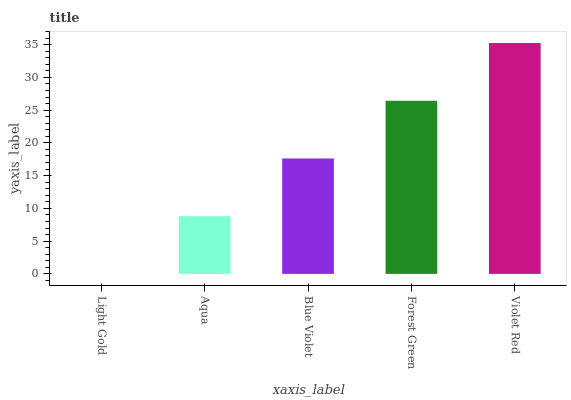Is Light Gold the minimum?
Answer yes or no. Yes. Is Violet Red the maximum?
Answer yes or no. Yes. Is Aqua the minimum?
Answer yes or no. No. Is Aqua the maximum?
Answer yes or no. No. Is Aqua greater than Light Gold?
Answer yes or no. Yes. Is Light Gold less than Aqua?
Answer yes or no. Yes. Is Light Gold greater than Aqua?
Answer yes or no. No. Is Aqua less than Light Gold?
Answer yes or no. No. Is Blue Violet the high median?
Answer yes or no. Yes. Is Blue Violet the low median?
Answer yes or no. Yes. Is Aqua the high median?
Answer yes or no. No. Is Violet Red the low median?
Answer yes or no. No. 